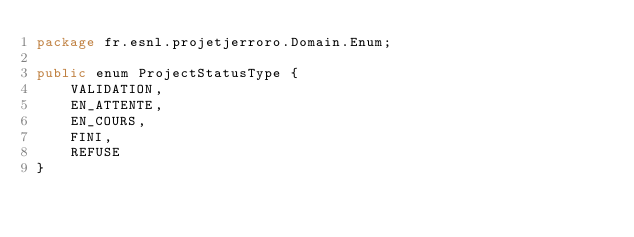<code> <loc_0><loc_0><loc_500><loc_500><_Java_>package fr.esnl.projetjerroro.Domain.Enum;

public enum ProjectStatusType {
    VALIDATION,
    EN_ATTENTE,
    EN_COURS,
    FINI,
    REFUSE
}
</code> 